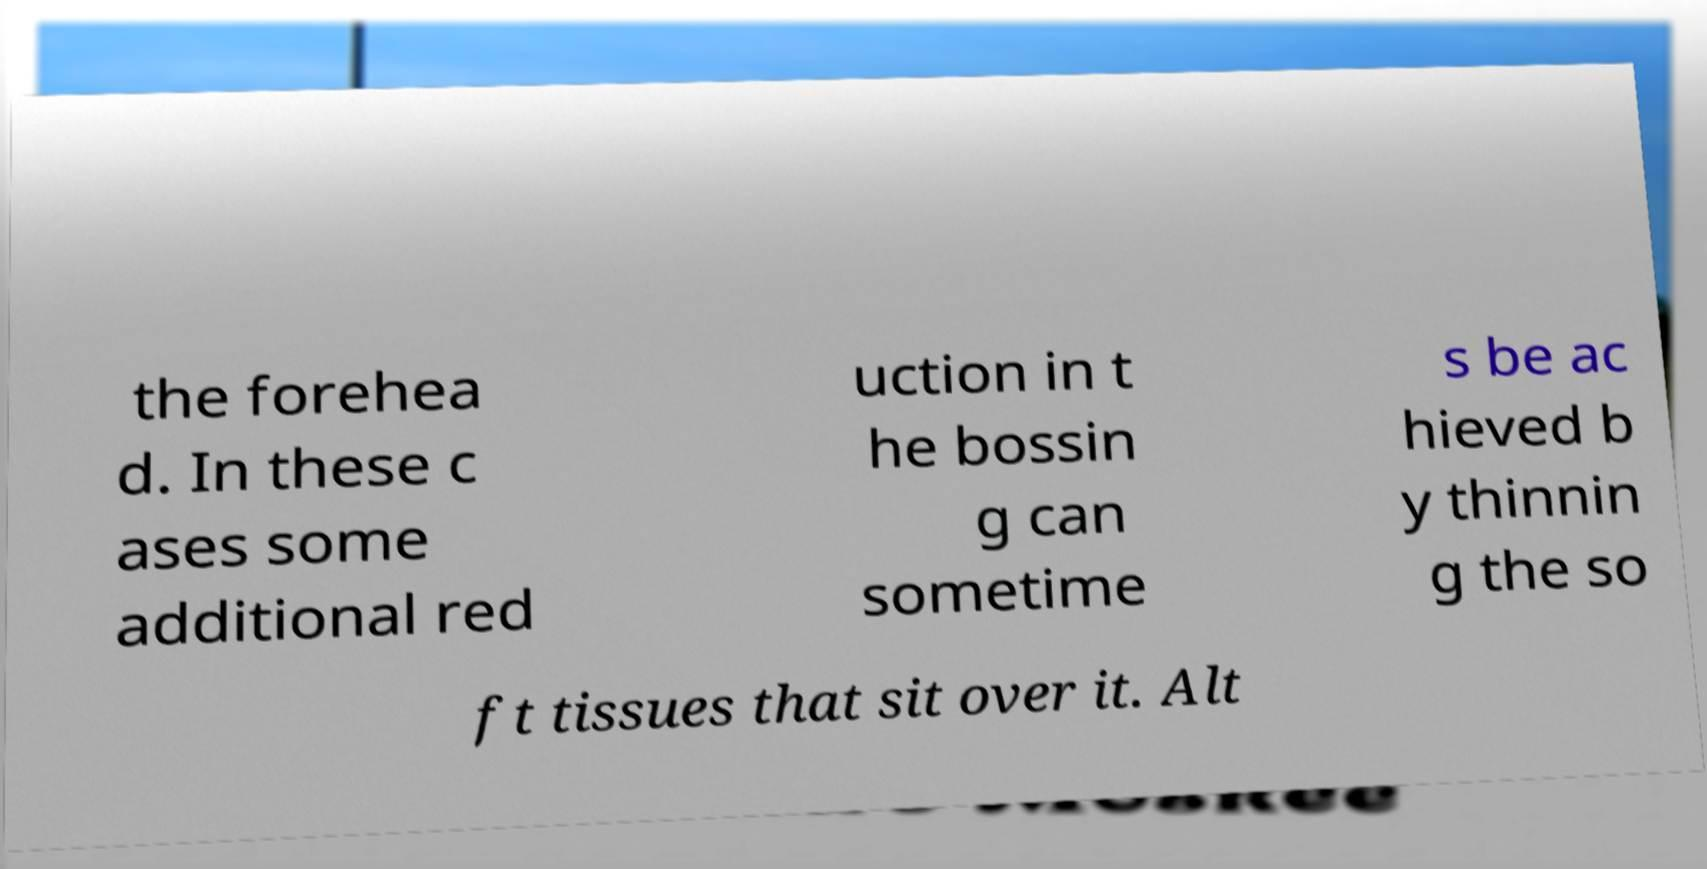Could you assist in decoding the text presented in this image and type it out clearly? the forehea d. In these c ases some additional red uction in t he bossin g can sometime s be ac hieved b y thinnin g the so ft tissues that sit over it. Alt 